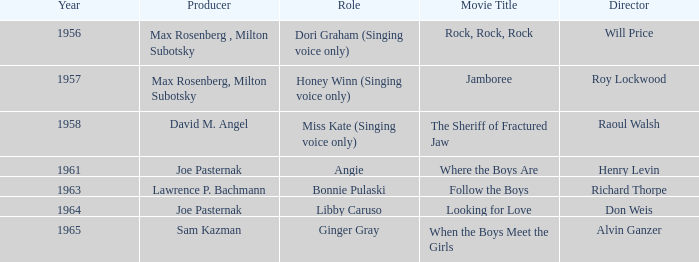What movie was made in 1957? Jamboree. 